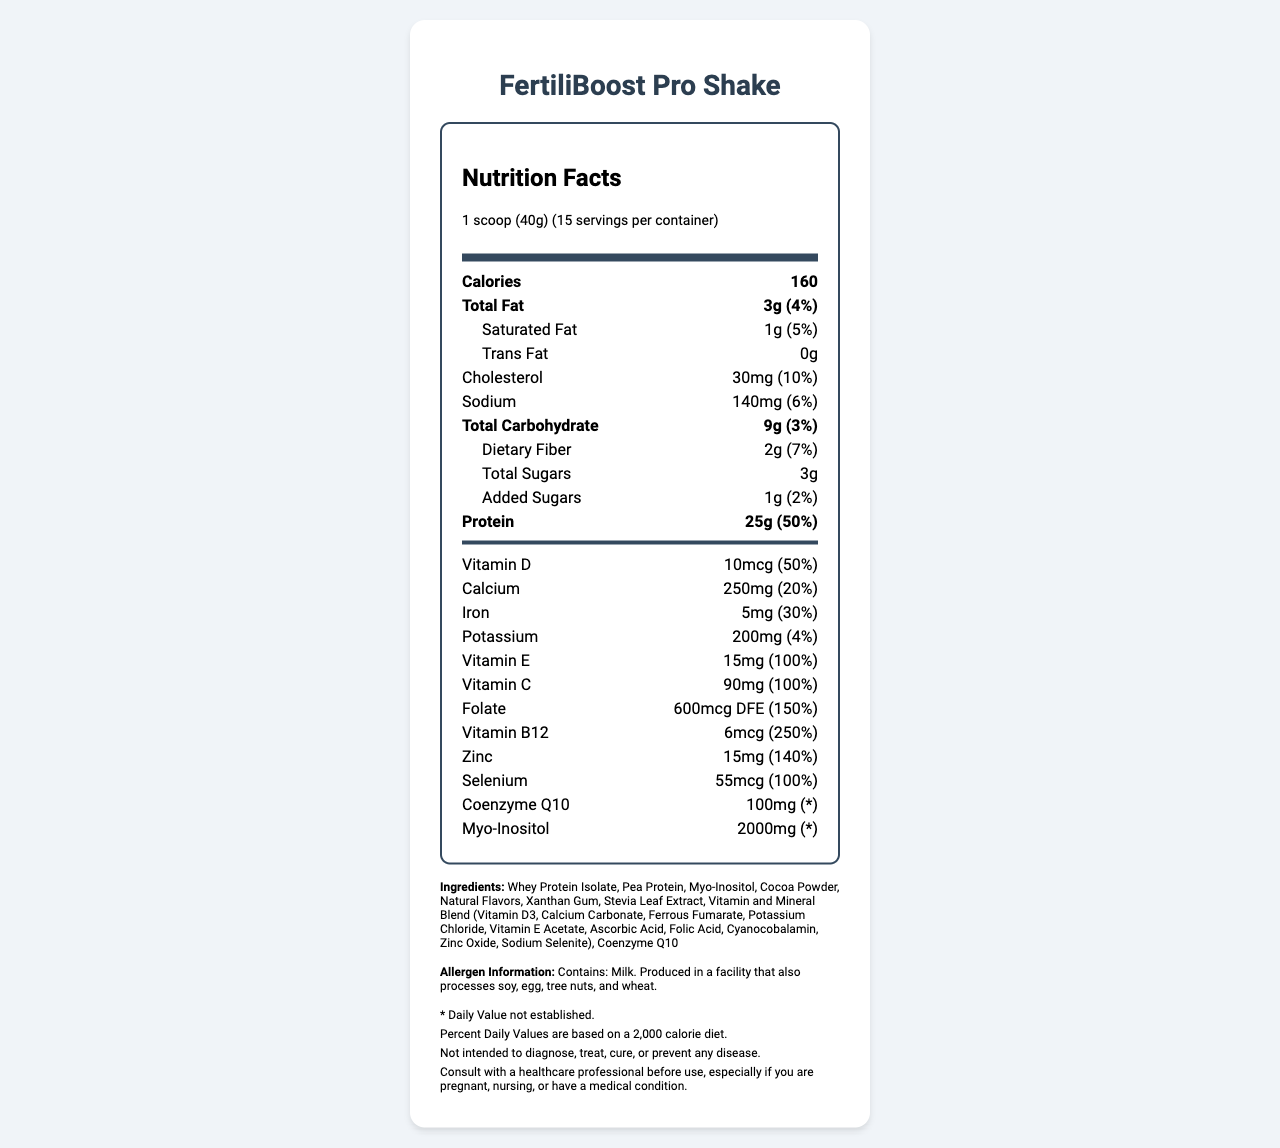what is the serving size for the FertiliBoost Pro Shake? The serving size is stated explicitly at the top of the Nutrition Facts section.
Answer: 1 scoop (40g) how many calories are there per serving? The total calories per serving is clearly mentioned near the top of the Nutrition Facts section.
Answer: 160 how much protein does each serving contain? The amount of protein per serving is listed, along with its percentage of the daily value.
Answer: 25g what vitamins are included in the ingredients list? The vitamins are part of the listed ingredients under the "Vitamin and Mineral Blend".
Answer: Vitamin D3, Vitamin E Acetate, Vitamin C (Ascorbic Acid), Folic Acid, Cyanocobalamin (Vitamin B12) what is the product name? The product name is given at the very top of the document and highlighted as the title.
Answer: FertiliBoost Pro Shake what are the daily values for Vitamin E and Vitamin C? These percentages are listed next to the amounts of the vitamins in the Vitamins section of the Nutrition Facts.
Answer: Vitamin E is 100%, Vitamin C is 100% what is the amount of Myo-Inositol in each serving? A. 100mg B. 500mg C. 2000mg D. 3000mg The amount of Myo-Inositol per serving is specified in the Vitamins and Minerals section.
Answer: C. 2000mg which vitamin has the highest daily value percentage? 1. Vitamin D 2. Folate 3. Vitamin B12 4. Zinc Vitamin B12 has a daily value percentage of 250%, which is the highest among the listed vitamins and minerals.
Answer: 3. Vitamin B12 is there any trans fat in the FertiliBoost Pro Shake? The trans fat amount is clearly listed as 0g.
Answer: No summarize the information provided in the document. The document provides detailed nutritional information for the FertiliBoost Pro Shake, including its macronutrient breakdown, vitamins and minerals content, ingredients, and allergen information.
Answer: The FertiliBoost Pro Shake is a specialized fertility-boosting protein shake that contains various vitamins and minerals. It has a serving size of 1 scoop (40g) with 15 servings per container. Each serving contains 160 calories, 3g total fat, 9g total carbohydrates, and 25g protein. The shake includes vitamins such as Vitamin D, E, and C, minerals like Calcium and Iron, and additional ingredients like Coenzyme Q10 and Myo-Inositol. It contains milk and may have traces of soy, egg, tree nuts, and wheat. how much sodium is there per serving, and what percentage of the daily value does it represent? The sodium content per serving is listed along with the percentage of the daily value.
Answer: 140mg, 6% how many grams of dietary fiber are in each serving? The amount of dietary fiber per serving is listed along with its percentage of the daily value.
Answer: 2g what information is provided about allergens in the FertiliBoost Pro Shake? The allergens section lists the presence of milk and potential cross-contamination with other allergens.
Answer: Contains: Milk. Produced in a facility that also processes soy, egg, tree nuts, and wheat. what flavors are used in the FertiliBoost Pro Shake? The ingredients list natural flavors in the composition of the shake.
Answer: Natural Flavors does the document indicate the percentage of daily value for Coenzyme Q10? The daily value for Coenzyme Q10 is marked with an asterisk and a disclaimer that says the daily value is not established.
Answer: No does the FertiliBoost Pro Shake contain any added sugars? The added sugars per serving and their daily value percentage are listed in the Nutrition Facts.
Answer: Yes, 1g what are the sources of protein in the FertiliBoost Pro Shake? These protein sources are listed in the ingredients section.
Answer: Whey Protein Isolate, Pea Protein how much cholesterol is there in each serving, and what percentage of the daily value does it represent? The cholesterol content and its percentage of the daily value are listed in the Nutrition Facts.
Answer: 30mg, 10% what is the amount of Vitamin A in each serving? The document does not provide any information about the amount or daily value percentage of Vitamin A.
Answer: Cannot be determined 